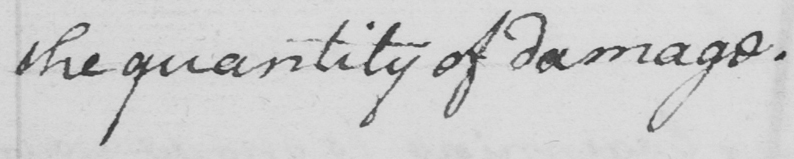Can you tell me what this handwritten text says? the quality of damage. 